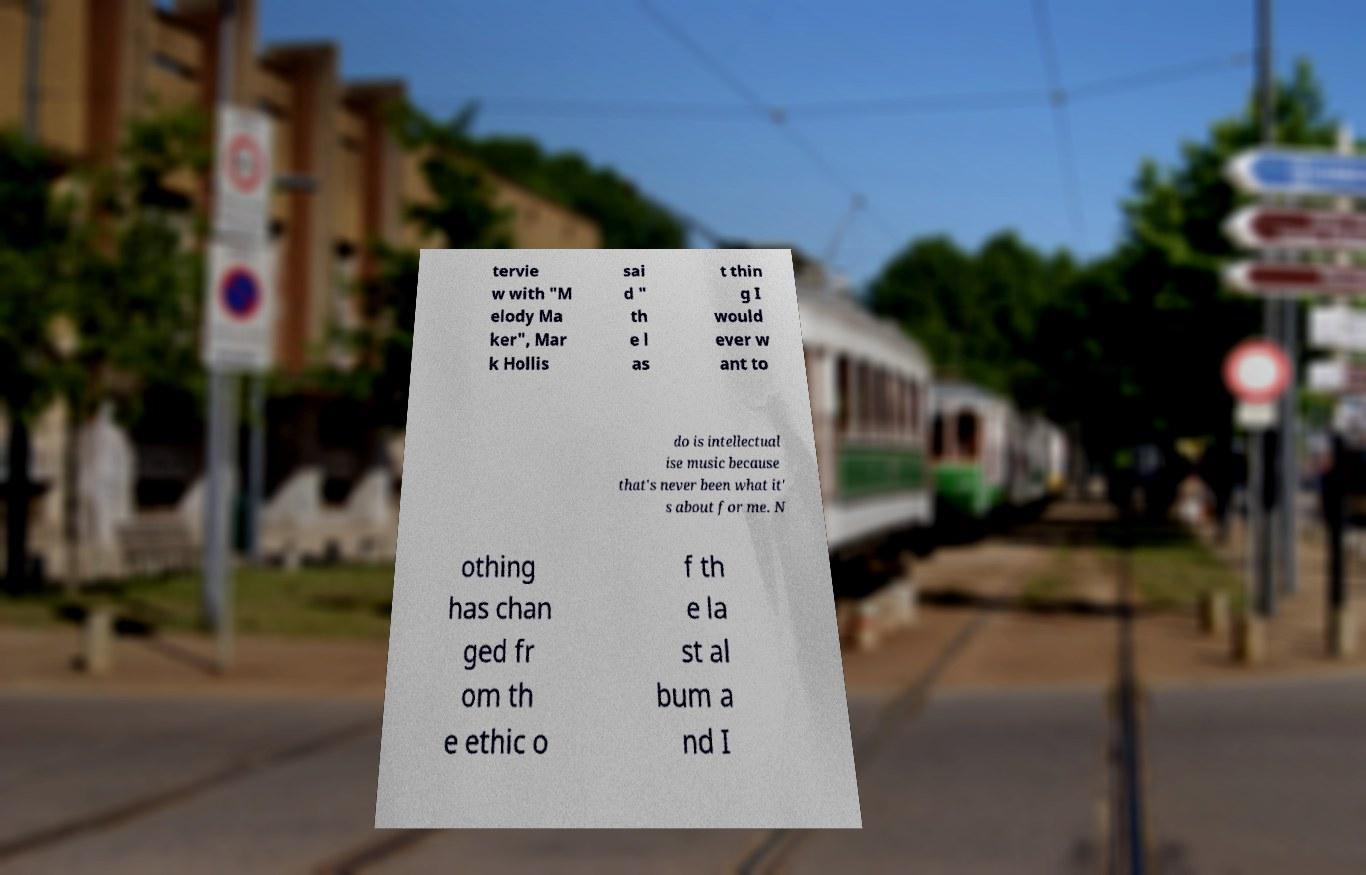For documentation purposes, I need the text within this image transcribed. Could you provide that? tervie w with "M elody Ma ker", Mar k Hollis sai d " th e l as t thin g I would ever w ant to do is intellectual ise music because that's never been what it' s about for me. N othing has chan ged fr om th e ethic o f th e la st al bum a nd I 